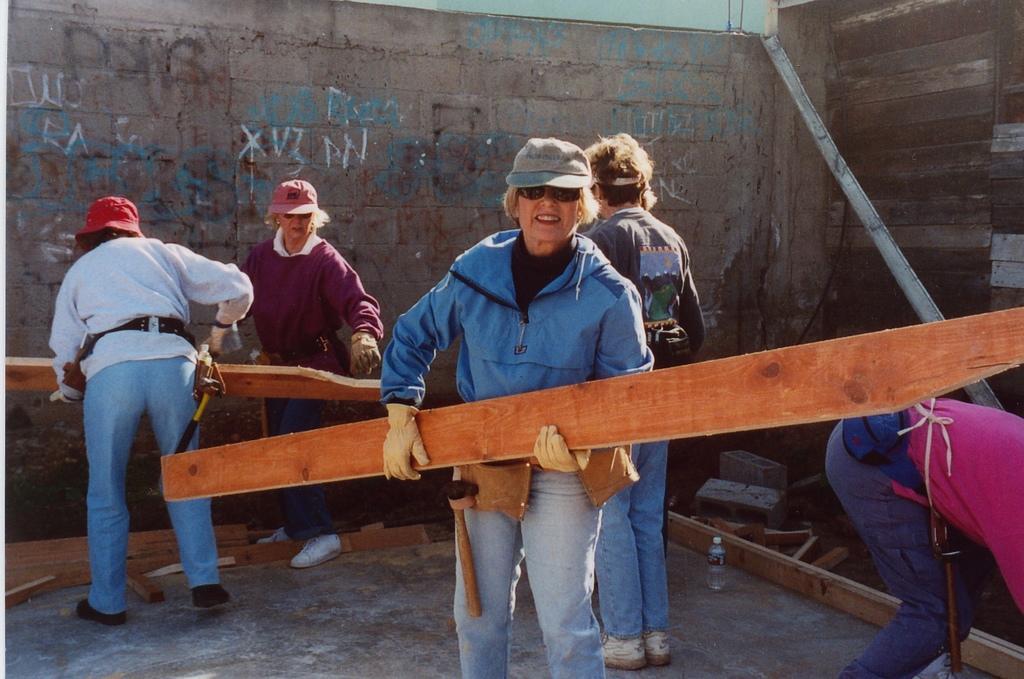Could you give a brief overview of what you see in this image? There is a lady holding a wooden stick in the foreground area of the image, there are people, walls and some objects in the background. 